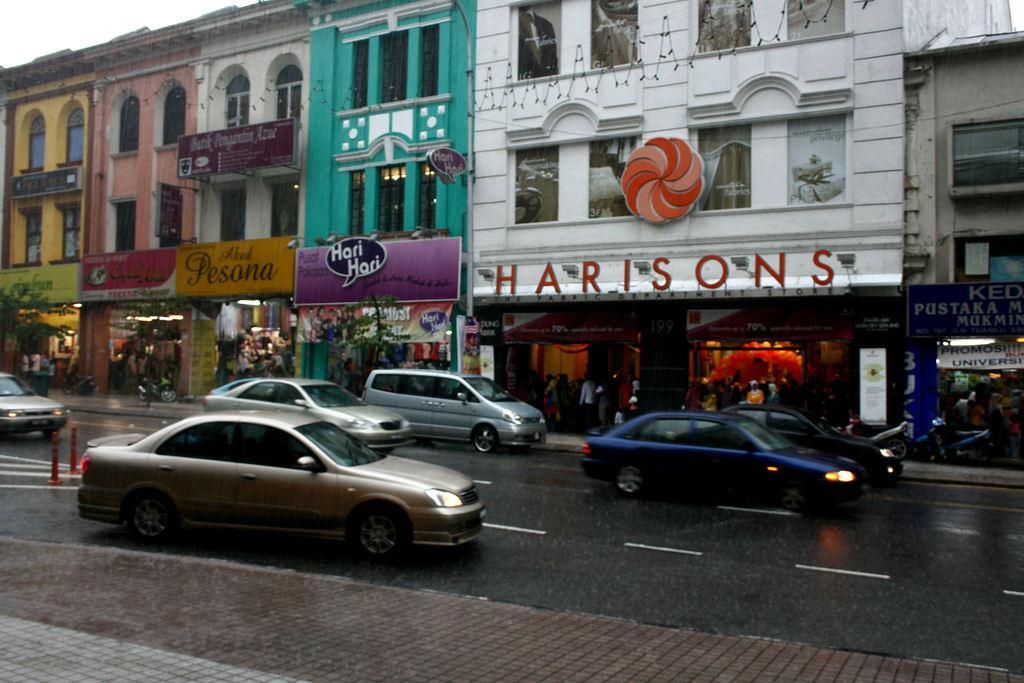What type of surface is in the foreground of the image? There is pavement in the foreground of the image. What is happening on the pavement in the image? Vehicles are moving on the road in the foreground. What can be seen in the background of the image? There are buildings and boards in the background of the image. What is visible above the buildings and boards in the image? The sky is visible in the background. What type of glue is being used to hold the buildings together in the image? There is no indication in the image that any glue is being used to hold the buildings together; they are likely constructed with other materials. What do you believe the people in the image are thinking? We cannot determine the thoughts of the people in the image based on the provided facts. 